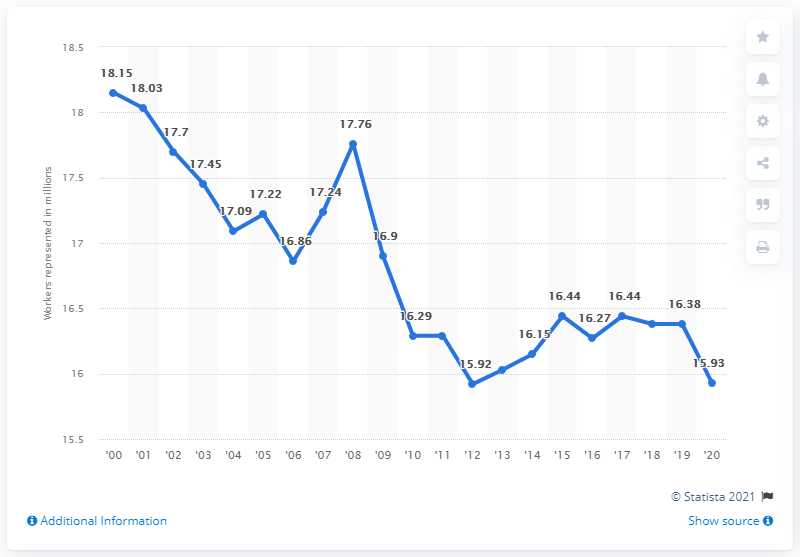Mention a couple of crucial points in this snapshot. In 2020, 15.93 workers were represented by unions. 